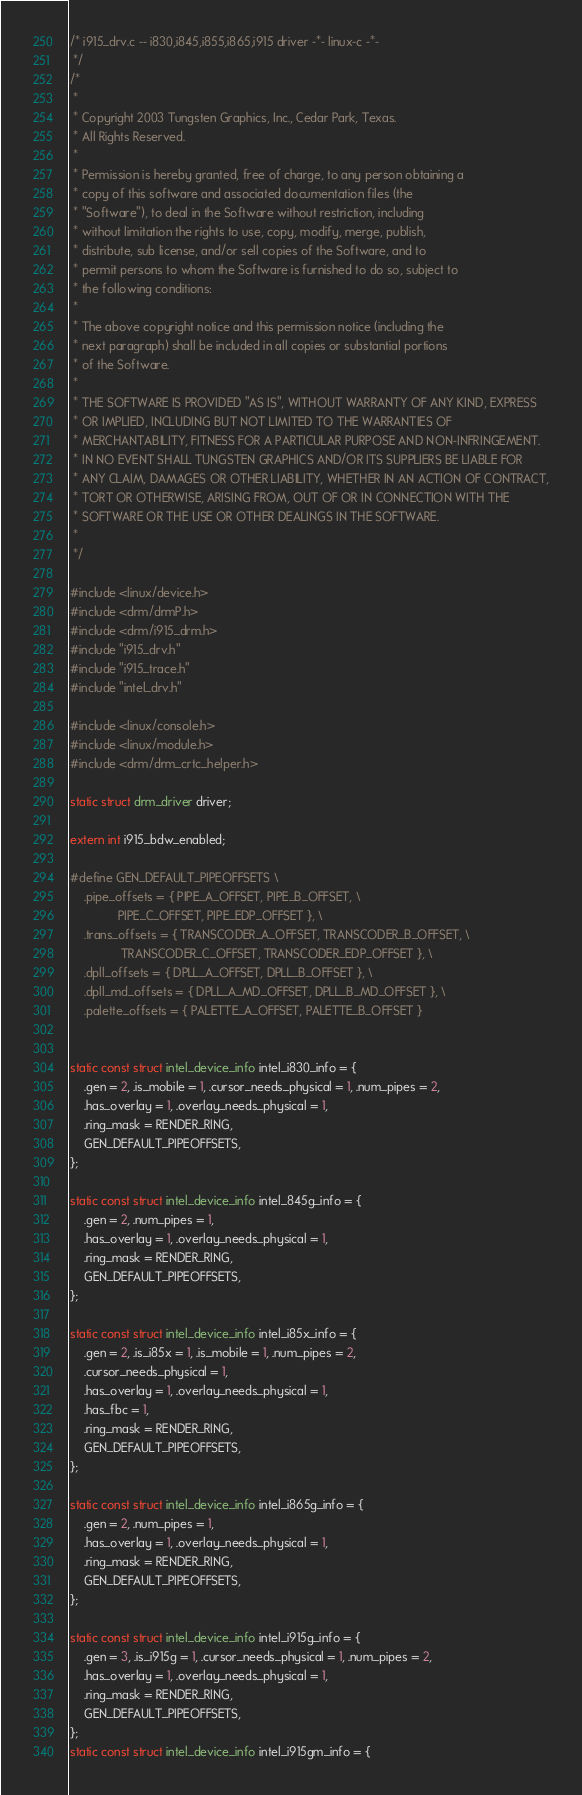Convert code to text. <code><loc_0><loc_0><loc_500><loc_500><_C_>/* i915_drv.c -- i830,i845,i855,i865,i915 driver -*- linux-c -*-
 */
/*
 *
 * Copyright 2003 Tungsten Graphics, Inc., Cedar Park, Texas.
 * All Rights Reserved.
 *
 * Permission is hereby granted, free of charge, to any person obtaining a
 * copy of this software and associated documentation files (the
 * "Software"), to deal in the Software without restriction, including
 * without limitation the rights to use, copy, modify, merge, publish,
 * distribute, sub license, and/or sell copies of the Software, and to
 * permit persons to whom the Software is furnished to do so, subject to
 * the following conditions:
 *
 * The above copyright notice and this permission notice (including the
 * next paragraph) shall be included in all copies or substantial portions
 * of the Software.
 *
 * THE SOFTWARE IS PROVIDED "AS IS", WITHOUT WARRANTY OF ANY KIND, EXPRESS
 * OR IMPLIED, INCLUDING BUT NOT LIMITED TO THE WARRANTIES OF
 * MERCHANTABILITY, FITNESS FOR A PARTICULAR PURPOSE AND NON-INFRINGEMENT.
 * IN NO EVENT SHALL TUNGSTEN GRAPHICS AND/OR ITS SUPPLIERS BE LIABLE FOR
 * ANY CLAIM, DAMAGES OR OTHER LIABILITY, WHETHER IN AN ACTION OF CONTRACT,
 * TORT OR OTHERWISE, ARISING FROM, OUT OF OR IN CONNECTION WITH THE
 * SOFTWARE OR THE USE OR OTHER DEALINGS IN THE SOFTWARE.
 *
 */

#include <linux/device.h>
#include <drm/drmP.h>
#include <drm/i915_drm.h>
#include "i915_drv.h"
#include "i915_trace.h"
#include "intel_drv.h"

#include <linux/console.h>
#include <linux/module.h>
#include <drm/drm_crtc_helper.h>

static struct drm_driver driver;

extern int i915_bdw_enabled;

#define GEN_DEFAULT_PIPEOFFSETS \
	.pipe_offsets = { PIPE_A_OFFSET, PIPE_B_OFFSET, \
			  PIPE_C_OFFSET, PIPE_EDP_OFFSET }, \
	.trans_offsets = { TRANSCODER_A_OFFSET, TRANSCODER_B_OFFSET, \
			   TRANSCODER_C_OFFSET, TRANSCODER_EDP_OFFSET }, \
	.dpll_offsets = { DPLL_A_OFFSET, DPLL_B_OFFSET }, \
	.dpll_md_offsets = { DPLL_A_MD_OFFSET, DPLL_B_MD_OFFSET }, \
	.palette_offsets = { PALETTE_A_OFFSET, PALETTE_B_OFFSET }


static const struct intel_device_info intel_i830_info = {
	.gen = 2, .is_mobile = 1, .cursor_needs_physical = 1, .num_pipes = 2,
	.has_overlay = 1, .overlay_needs_physical = 1,
	.ring_mask = RENDER_RING,
	GEN_DEFAULT_PIPEOFFSETS,
};

static const struct intel_device_info intel_845g_info = {
	.gen = 2, .num_pipes = 1,
	.has_overlay = 1, .overlay_needs_physical = 1,
	.ring_mask = RENDER_RING,
	GEN_DEFAULT_PIPEOFFSETS,
};

static const struct intel_device_info intel_i85x_info = {
	.gen = 2, .is_i85x = 1, .is_mobile = 1, .num_pipes = 2,
	.cursor_needs_physical = 1,
	.has_overlay = 1, .overlay_needs_physical = 1,
	.has_fbc = 1,
	.ring_mask = RENDER_RING,
	GEN_DEFAULT_PIPEOFFSETS,
};

static const struct intel_device_info intel_i865g_info = {
	.gen = 2, .num_pipes = 1,
	.has_overlay = 1, .overlay_needs_physical = 1,
	.ring_mask = RENDER_RING,
	GEN_DEFAULT_PIPEOFFSETS,
};

static const struct intel_device_info intel_i915g_info = {
	.gen = 3, .is_i915g = 1, .cursor_needs_physical = 1, .num_pipes = 2,
	.has_overlay = 1, .overlay_needs_physical = 1,
	.ring_mask = RENDER_RING,
	GEN_DEFAULT_PIPEOFFSETS,
};
static const struct intel_device_info intel_i915gm_info = {</code> 